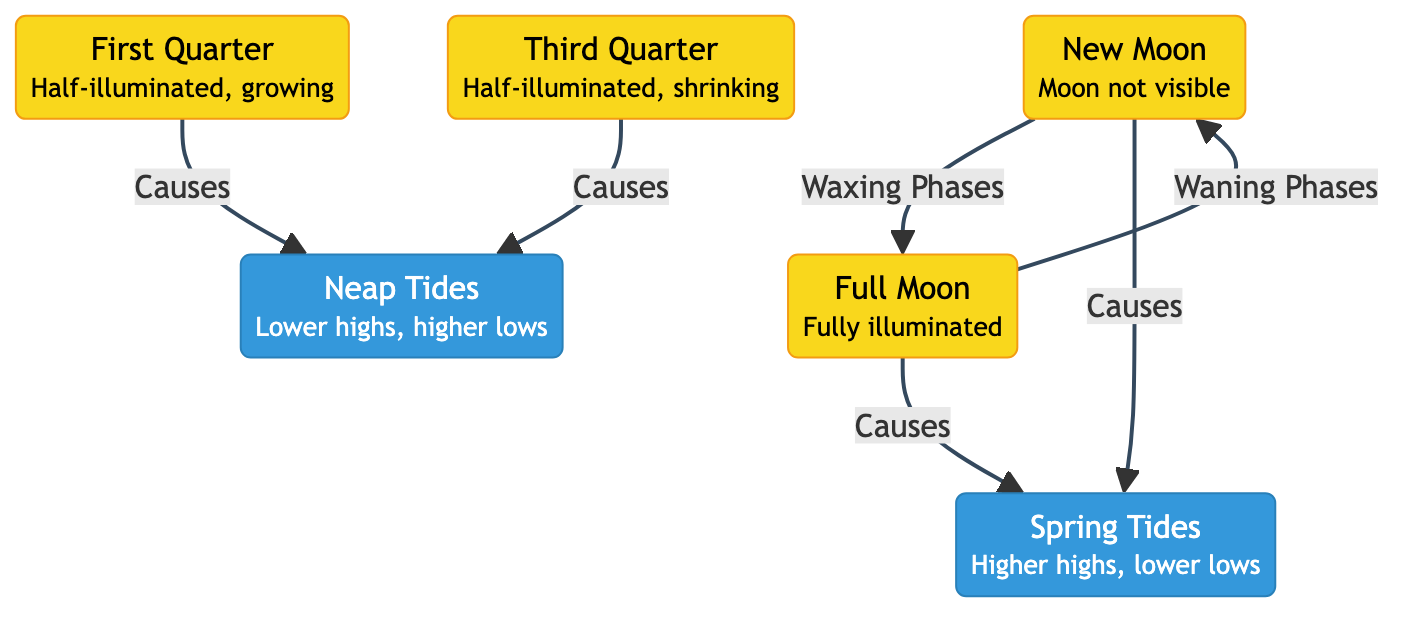What are the two main types of tides mentioned in the diagram? From the diagram, the two types of tides identified are "Spring Tides" and "Neap Tides." These terms are explicitly labeled in separate nodes.
Answer: Spring Tides and Neap Tides How many moon phases are there in the diagram? The diagram includes four distinct moon phases: New Moon, First Quarter, Full Moon, and Third Quarter. Each of these phases is represented as a separate node.
Answer: Four What causes spring tides? According to the diagram, spring tides are caused by both the New Moon and the Full Moon, as indicated by the arrows pointing from these phases to the "Spring Tides" node.
Answer: New Moon and Full Moon What happens to the tides during a third quarter moon? The diagram indicates that during a Third Quarter moon, Neap Tides occur, as the Third Quarter node has an arrow pointing to the Neap Tides node.
Answer: Neap Tides Which moon phases are associated with neap tides? The diagram shows that neap tides are caused by both the First Quarter and Third Quarter moon phases, as these phases have arrows leading to the Neap Tides node.
Answer: First Quarter and Third Quarter How does the moon transition from a new moon to a full moon? The transition from a New Moon to a Full Moon is indicated in the diagram as a sequence of Waxing Phases, where the New Moon leads directly to the Full Moon node.
Answer: Waxing Phases What is the visibility status of the moon during a new moon? The diagram explicitly states that during a New Moon, the moon is "not visible," which is mentioned in the description attached to the New Moon node.
Answer: Not visible What type of tidal changes occur during spring tides? The diagram describes spring tides as having "Higher highs, lower lows," which characterizes the tidal changes associated with this type of tide.
Answer: Higher highs, lower lows 